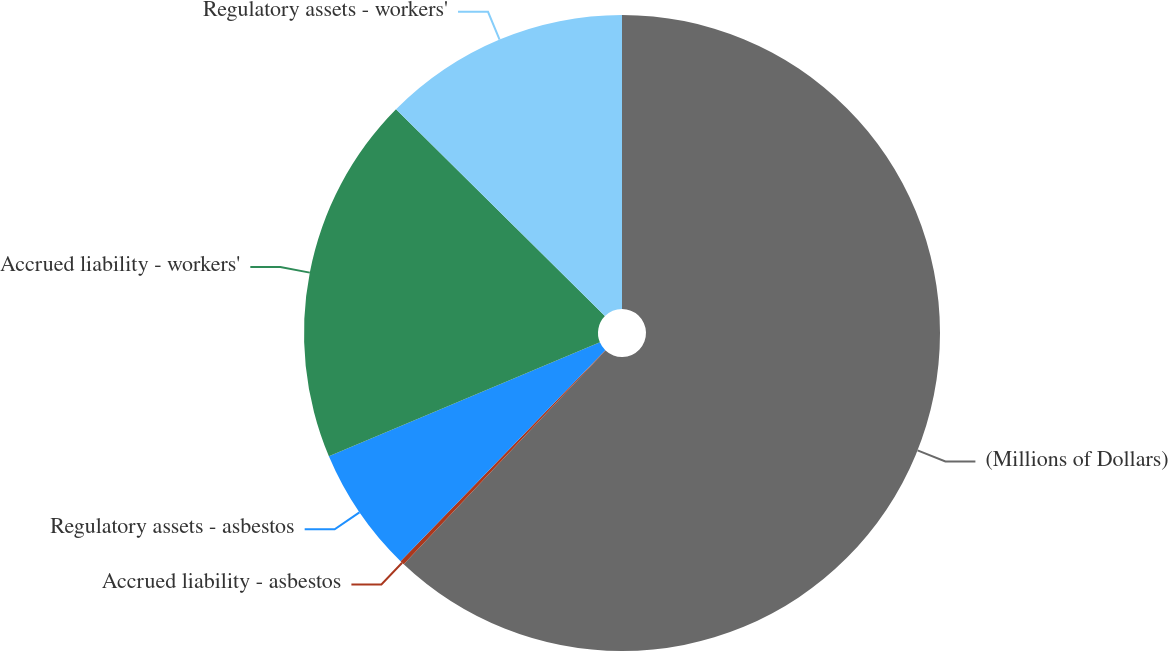<chart> <loc_0><loc_0><loc_500><loc_500><pie_chart><fcel>(Millions of Dollars)<fcel>Accrued liability - asbestos<fcel>Regulatory assets - asbestos<fcel>Accrued liability - workers'<fcel>Regulatory assets - workers'<nl><fcel>62.04%<fcel>0.22%<fcel>6.4%<fcel>18.76%<fcel>12.58%<nl></chart> 